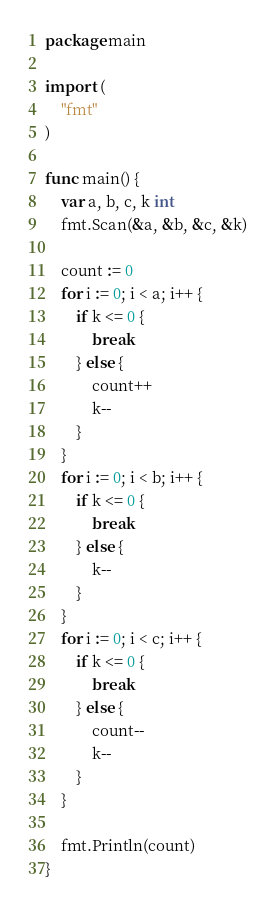Convert code to text. <code><loc_0><loc_0><loc_500><loc_500><_Go_>package main

import (
	"fmt"
)

func main() {
	var a, b, c, k int
	fmt.Scan(&a, &b, &c, &k)

	count := 0
	for i := 0; i < a; i++ {
		if k <= 0 {
			break
		} else {
			count++
			k--
		}
	}
	for i := 0; i < b; i++ {
		if k <= 0 {
			break
		} else {
			k--
		}
	}
	for i := 0; i < c; i++ {
		if k <= 0 {
			break
		} else {
			count--
			k--
		}
	}

	fmt.Println(count)
}
</code> 